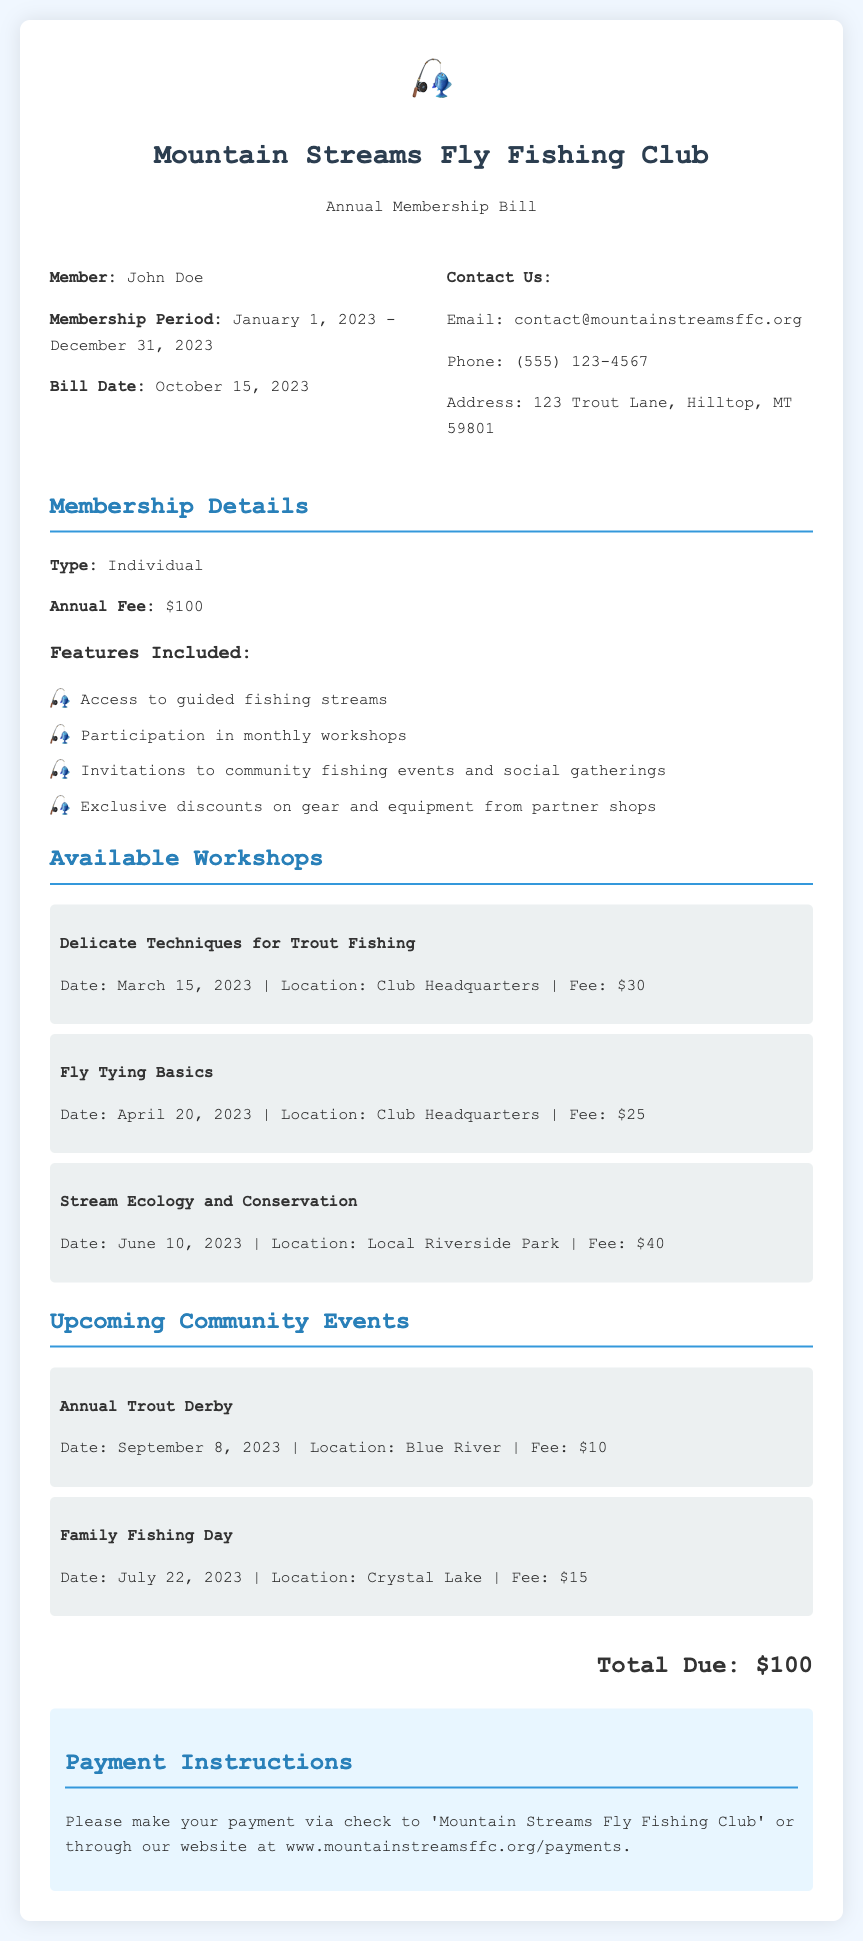What is the member's name? The member's name is displayed in the bill information section.
Answer: John Doe What is the membership period? The membership period is stated in the bill information section.
Answer: January 1, 2023 - December 31, 2023 What is the annual fee? The annual fee is listed under membership details in the document.
Answer: $100 How many workshops are listed? The number of workshops can be counted in the workshops section of the document.
Answer: 3 What is the date of the Annual Trout Derby? The date for the Annual Trout Derby is mentioned in the community events section.
Answer: September 8, 2023 What is the total due amount? The total due amount is located in the total section of the document.
Answer: $100 What is the fee for the Fly Tying Basics workshop? The fee for the Fly Tying Basics workshop can be found in the workshops section.
Answer: $25 What payment methods are accepted? The payment methods are specified in the payment instructions at the bottom of the document.
Answer: Check or website payment What feature is not included in the membership? Features included in the membership are listed in the membership details section, implying one that is not mentioned.
Answer: None (all features are included) 